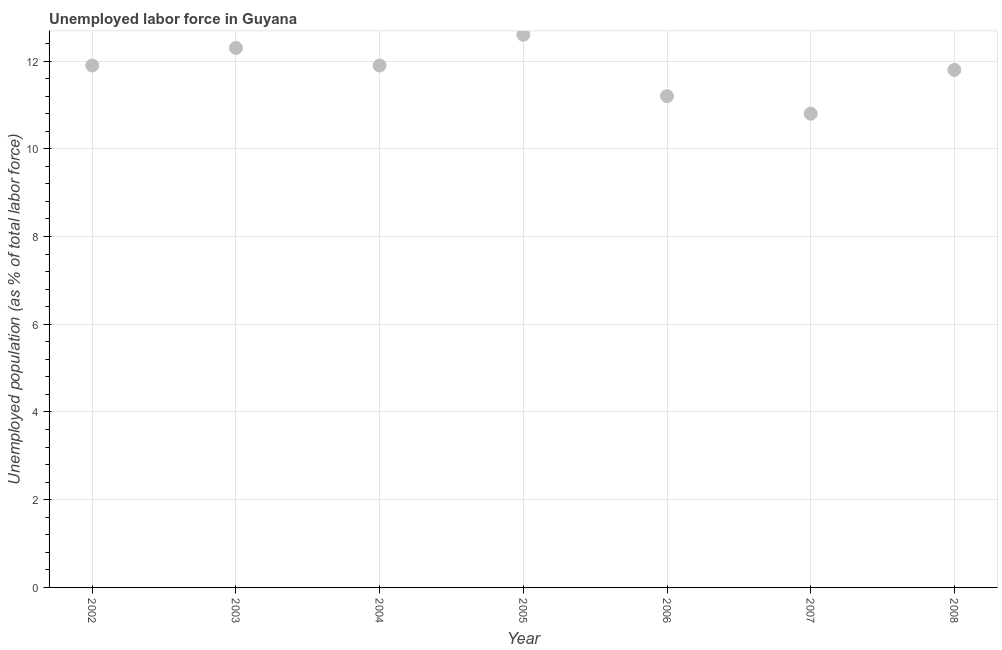What is the total unemployed population in 2004?
Keep it short and to the point. 11.9. Across all years, what is the maximum total unemployed population?
Keep it short and to the point. 12.6. Across all years, what is the minimum total unemployed population?
Offer a very short reply. 10.8. What is the sum of the total unemployed population?
Make the answer very short. 82.5. What is the difference between the total unemployed population in 2002 and 2006?
Offer a terse response. 0.7. What is the average total unemployed population per year?
Offer a terse response. 11.79. What is the median total unemployed population?
Keep it short and to the point. 11.9. What is the ratio of the total unemployed population in 2002 to that in 2006?
Your answer should be very brief. 1.06. Is the difference between the total unemployed population in 2004 and 2006 greater than the difference between any two years?
Offer a very short reply. No. What is the difference between the highest and the second highest total unemployed population?
Offer a very short reply. 0.3. What is the difference between the highest and the lowest total unemployed population?
Offer a terse response. 1.8. In how many years, is the total unemployed population greater than the average total unemployed population taken over all years?
Ensure brevity in your answer.  5. Are the values on the major ticks of Y-axis written in scientific E-notation?
Provide a short and direct response. No. Does the graph contain any zero values?
Provide a succinct answer. No. What is the title of the graph?
Give a very brief answer. Unemployed labor force in Guyana. What is the label or title of the Y-axis?
Provide a short and direct response. Unemployed population (as % of total labor force). What is the Unemployed population (as % of total labor force) in 2002?
Provide a short and direct response. 11.9. What is the Unemployed population (as % of total labor force) in 2003?
Provide a short and direct response. 12.3. What is the Unemployed population (as % of total labor force) in 2004?
Your answer should be compact. 11.9. What is the Unemployed population (as % of total labor force) in 2005?
Ensure brevity in your answer.  12.6. What is the Unemployed population (as % of total labor force) in 2006?
Your response must be concise. 11.2. What is the Unemployed population (as % of total labor force) in 2007?
Give a very brief answer. 10.8. What is the Unemployed population (as % of total labor force) in 2008?
Keep it short and to the point. 11.8. What is the difference between the Unemployed population (as % of total labor force) in 2002 and 2003?
Offer a very short reply. -0.4. What is the difference between the Unemployed population (as % of total labor force) in 2002 and 2005?
Your response must be concise. -0.7. What is the difference between the Unemployed population (as % of total labor force) in 2002 and 2008?
Make the answer very short. 0.1. What is the difference between the Unemployed population (as % of total labor force) in 2003 and 2004?
Provide a succinct answer. 0.4. What is the difference between the Unemployed population (as % of total labor force) in 2003 and 2006?
Keep it short and to the point. 1.1. What is the difference between the Unemployed population (as % of total labor force) in 2004 and 2005?
Provide a short and direct response. -0.7. What is the difference between the Unemployed population (as % of total labor force) in 2004 and 2007?
Make the answer very short. 1.1. What is the difference between the Unemployed population (as % of total labor force) in 2006 and 2007?
Provide a short and direct response. 0.4. What is the difference between the Unemployed population (as % of total labor force) in 2006 and 2008?
Your answer should be compact. -0.6. What is the ratio of the Unemployed population (as % of total labor force) in 2002 to that in 2004?
Your answer should be compact. 1. What is the ratio of the Unemployed population (as % of total labor force) in 2002 to that in 2005?
Ensure brevity in your answer.  0.94. What is the ratio of the Unemployed population (as % of total labor force) in 2002 to that in 2006?
Keep it short and to the point. 1.06. What is the ratio of the Unemployed population (as % of total labor force) in 2002 to that in 2007?
Offer a very short reply. 1.1. What is the ratio of the Unemployed population (as % of total labor force) in 2003 to that in 2004?
Give a very brief answer. 1.03. What is the ratio of the Unemployed population (as % of total labor force) in 2003 to that in 2006?
Keep it short and to the point. 1.1. What is the ratio of the Unemployed population (as % of total labor force) in 2003 to that in 2007?
Make the answer very short. 1.14. What is the ratio of the Unemployed population (as % of total labor force) in 2003 to that in 2008?
Keep it short and to the point. 1.04. What is the ratio of the Unemployed population (as % of total labor force) in 2004 to that in 2005?
Provide a succinct answer. 0.94. What is the ratio of the Unemployed population (as % of total labor force) in 2004 to that in 2006?
Your response must be concise. 1.06. What is the ratio of the Unemployed population (as % of total labor force) in 2004 to that in 2007?
Your answer should be very brief. 1.1. What is the ratio of the Unemployed population (as % of total labor force) in 2005 to that in 2006?
Make the answer very short. 1.12. What is the ratio of the Unemployed population (as % of total labor force) in 2005 to that in 2007?
Give a very brief answer. 1.17. What is the ratio of the Unemployed population (as % of total labor force) in 2005 to that in 2008?
Your answer should be compact. 1.07. What is the ratio of the Unemployed population (as % of total labor force) in 2006 to that in 2007?
Provide a succinct answer. 1.04. What is the ratio of the Unemployed population (as % of total labor force) in 2006 to that in 2008?
Offer a terse response. 0.95. What is the ratio of the Unemployed population (as % of total labor force) in 2007 to that in 2008?
Your answer should be compact. 0.92. 